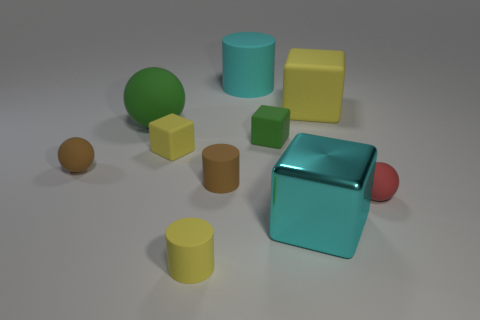There is another thing that is the same color as the metallic object; what is its size?
Offer a very short reply. Large. Is there a gray metallic cylinder that has the same size as the brown matte sphere?
Keep it short and to the point. No. What is the color of the other large object that is the same shape as the red matte object?
Keep it short and to the point. Green. There is a cyan object left of the tiny green matte thing; are there any big yellow things on the left side of it?
Keep it short and to the point. No. There is a small matte object in front of the large metal object; is its shape the same as the red rubber object?
Your response must be concise. No. What is the shape of the large metal object?
Your response must be concise. Cube. What number of small things have the same material as the tiny green cube?
Make the answer very short. 5. There is a shiny object; is it the same color as the block to the left of the big cyan matte cylinder?
Your answer should be very brief. No. How many yellow rubber cubes are there?
Provide a short and direct response. 2. Are there any small spheres of the same color as the big metallic block?
Provide a succinct answer. No. 